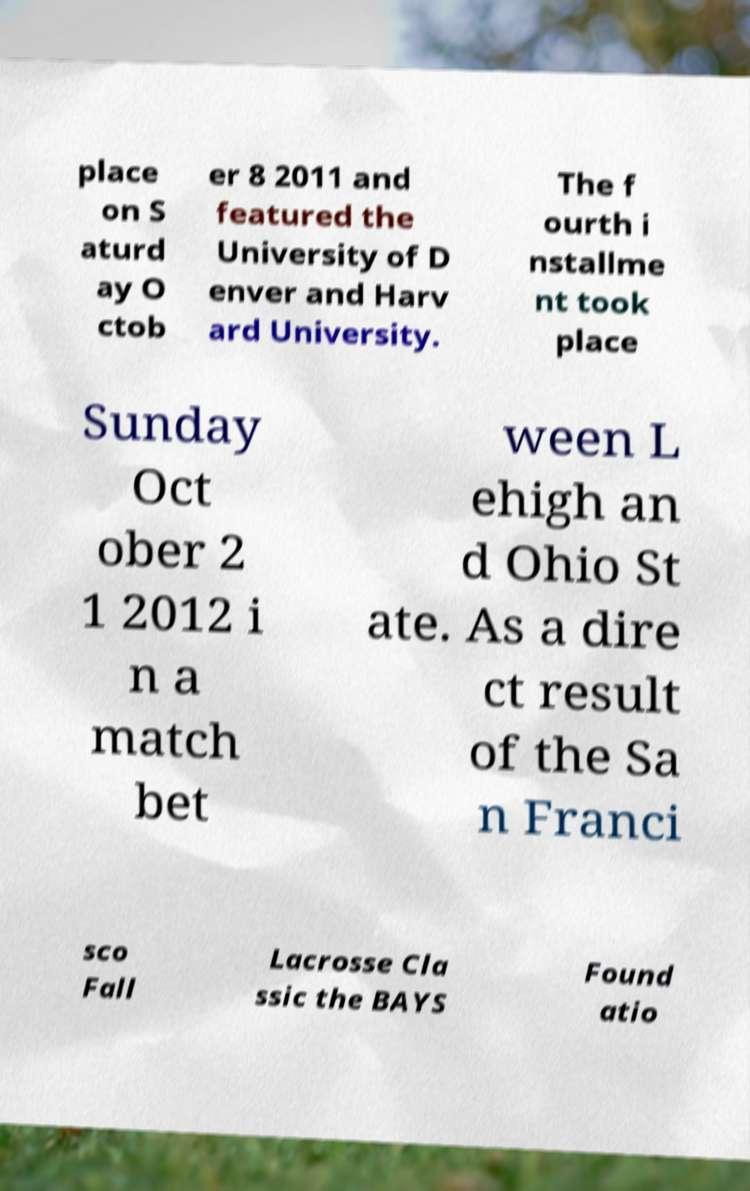Please identify and transcribe the text found in this image. place on S aturd ay O ctob er 8 2011 and featured the University of D enver and Harv ard University. The f ourth i nstallme nt took place Sunday Oct ober 2 1 2012 i n a match bet ween L ehigh an d Ohio St ate. As a dire ct result of the Sa n Franci sco Fall Lacrosse Cla ssic the BAYS Found atio 